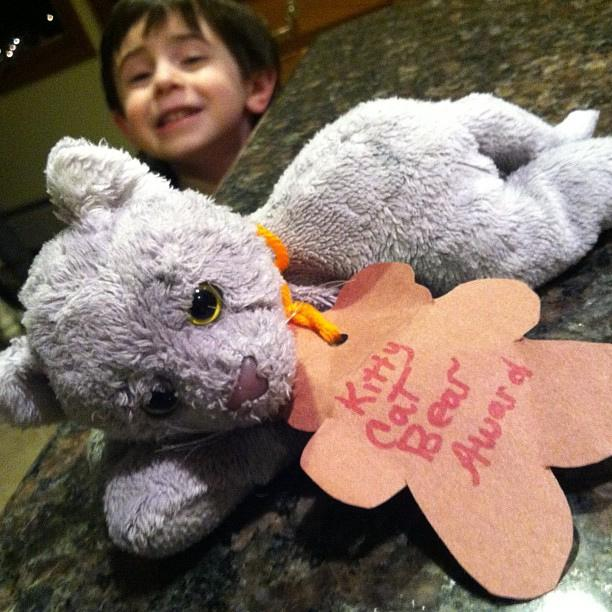What color is the twine wrapped around this little bear's neck? orange 